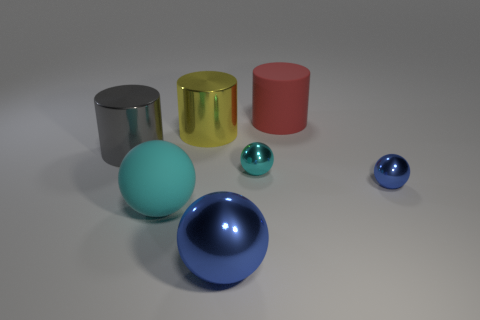The other sphere that is the same color as the large matte ball is what size?
Make the answer very short. Small. What material is the small object that is the same color as the big rubber sphere?
Provide a succinct answer. Metal. What number of other things are there of the same color as the matte sphere?
Provide a short and direct response. 1. What number of rubber things are either small things or small cyan objects?
Your response must be concise. 0. Are there any big red things made of the same material as the big red cylinder?
Provide a short and direct response. No. What number of objects are to the right of the red rubber object and in front of the tiny blue metallic ball?
Provide a succinct answer. 0. Are there fewer metal objects that are in front of the big yellow shiny cylinder than big blue objects that are behind the tiny blue metal sphere?
Your answer should be compact. No. Is the shape of the large yellow thing the same as the big blue object?
Your answer should be very brief. No. How many other things are there of the same size as the yellow object?
Your answer should be very brief. 4. What number of things are cyan spheres to the right of the large rubber sphere or big shiny cylinders in front of the yellow thing?
Offer a very short reply. 2. 